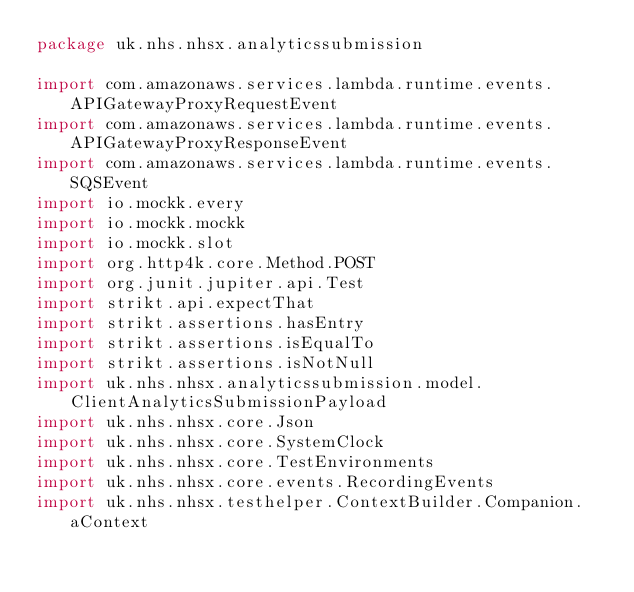<code> <loc_0><loc_0><loc_500><loc_500><_Kotlin_>package uk.nhs.nhsx.analyticssubmission

import com.amazonaws.services.lambda.runtime.events.APIGatewayProxyRequestEvent
import com.amazonaws.services.lambda.runtime.events.APIGatewayProxyResponseEvent
import com.amazonaws.services.lambda.runtime.events.SQSEvent
import io.mockk.every
import io.mockk.mockk
import io.mockk.slot
import org.http4k.core.Method.POST
import org.junit.jupiter.api.Test
import strikt.api.expectThat
import strikt.assertions.hasEntry
import strikt.assertions.isEqualTo
import strikt.assertions.isNotNull
import uk.nhs.nhsx.analyticssubmission.model.ClientAnalyticsSubmissionPayload
import uk.nhs.nhsx.core.Json
import uk.nhs.nhsx.core.SystemClock
import uk.nhs.nhsx.core.TestEnvironments
import uk.nhs.nhsx.core.events.RecordingEvents
import uk.nhs.nhsx.testhelper.ContextBuilder.Companion.aContext</code> 